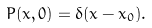<formula> <loc_0><loc_0><loc_500><loc_500>P ( x , 0 ) = \delta ( x - x _ { 0 } ) .</formula> 